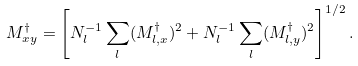<formula> <loc_0><loc_0><loc_500><loc_500>M ^ { \dagger } _ { x y } = \left [ N _ { l } ^ { - 1 } \sum _ { l } ( M _ { l , x } ^ { \dagger } ) ^ { 2 } + N _ { l } ^ { - 1 } \sum _ { l } ( M _ { l , y } ^ { \dagger } ) ^ { 2 } \right ] ^ { 1 / 2 } .</formula> 